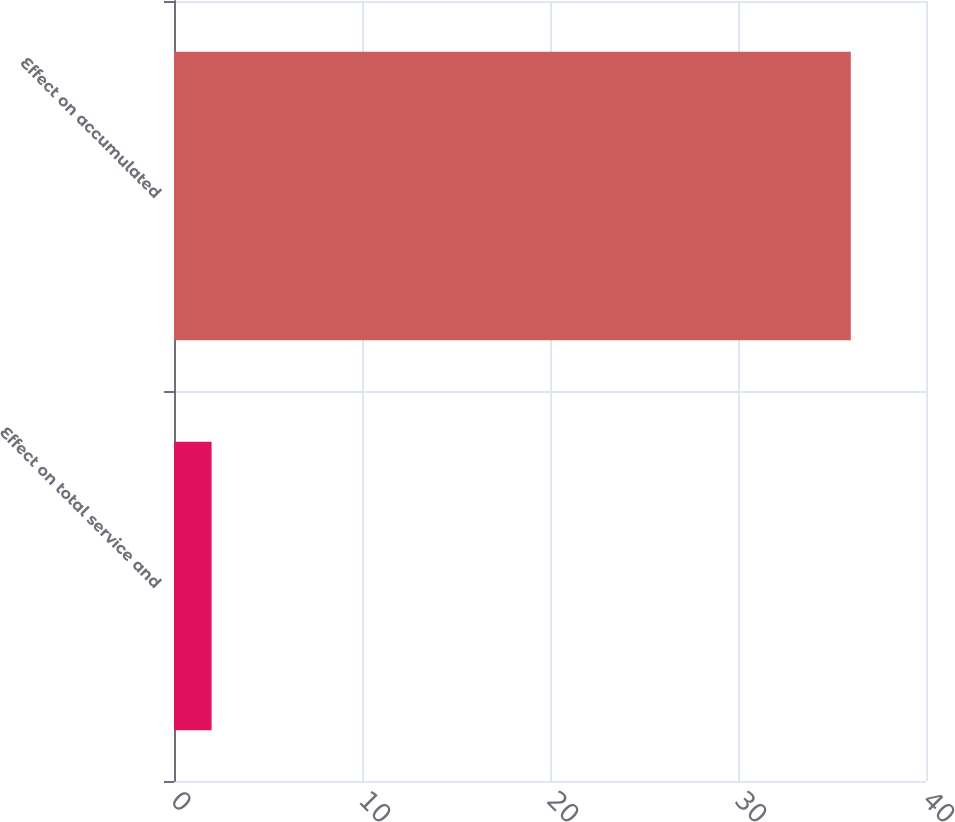<chart> <loc_0><loc_0><loc_500><loc_500><bar_chart><fcel>Effect on total service and<fcel>Effect on accumulated<nl><fcel>2<fcel>36<nl></chart> 